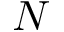Convert formula to latex. <formula><loc_0><loc_0><loc_500><loc_500>N</formula> 